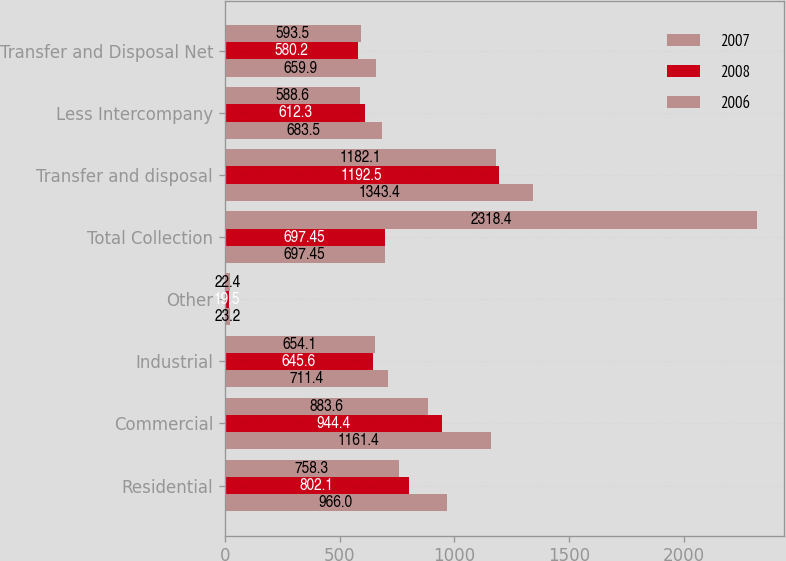<chart> <loc_0><loc_0><loc_500><loc_500><stacked_bar_chart><ecel><fcel>Residential<fcel>Commercial<fcel>Industrial<fcel>Other<fcel>Total Collection<fcel>Transfer and disposal<fcel>Less Intercompany<fcel>Transfer and Disposal Net<nl><fcel>2007<fcel>966<fcel>1161.4<fcel>711.4<fcel>23.2<fcel>697.45<fcel>1343.4<fcel>683.5<fcel>659.9<nl><fcel>2008<fcel>802.1<fcel>944.4<fcel>645.6<fcel>19.5<fcel>697.45<fcel>1192.5<fcel>612.3<fcel>580.2<nl><fcel>2006<fcel>758.3<fcel>883.6<fcel>654.1<fcel>22.4<fcel>2318.4<fcel>1182.1<fcel>588.6<fcel>593.5<nl></chart> 